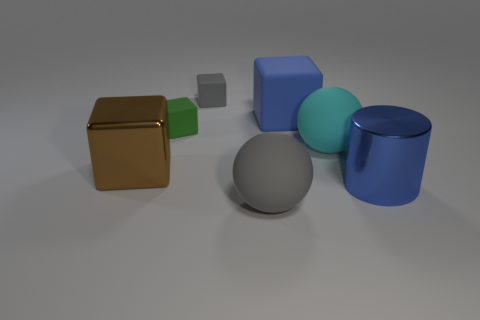Add 2 brown rubber objects. How many objects exist? 9 Subtract all cylinders. How many objects are left? 6 Add 4 green rubber things. How many green rubber things exist? 5 Subtract 0 brown spheres. How many objects are left? 7 Subtract all rubber balls. Subtract all large brown things. How many objects are left? 4 Add 3 large blue cylinders. How many large blue cylinders are left? 4 